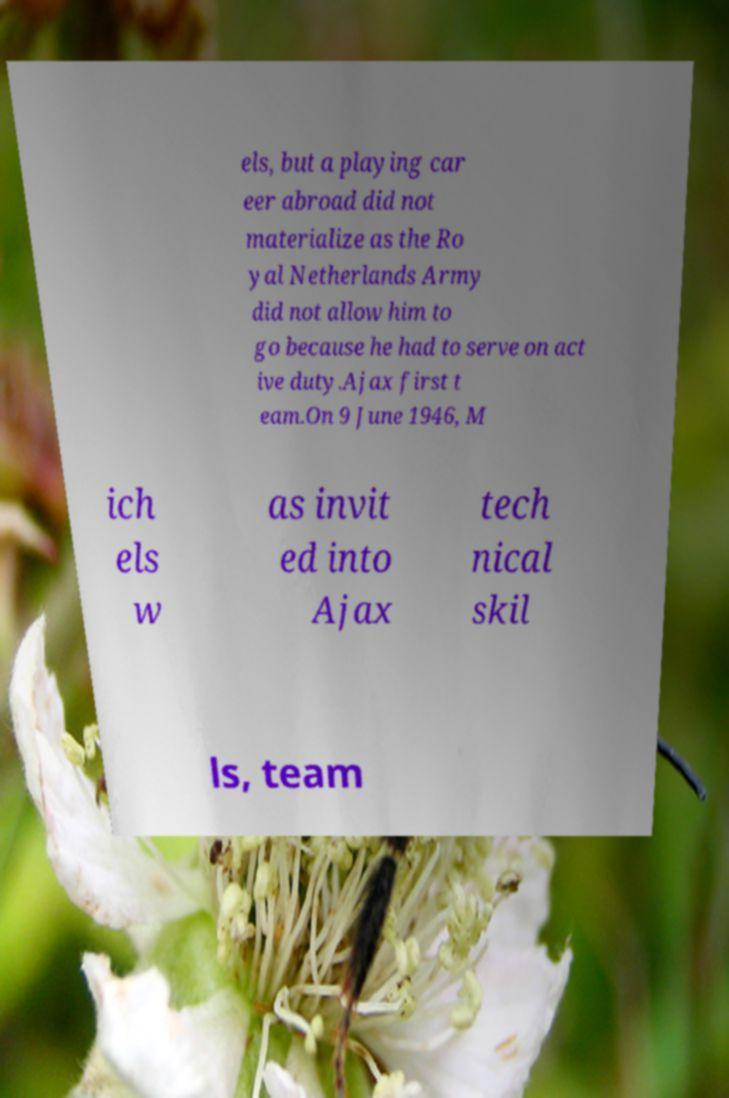Can you accurately transcribe the text from the provided image for me? els, but a playing car eer abroad did not materialize as the Ro yal Netherlands Army did not allow him to go because he had to serve on act ive duty.Ajax first t eam.On 9 June 1946, M ich els w as invit ed into Ajax tech nical skil ls, team 